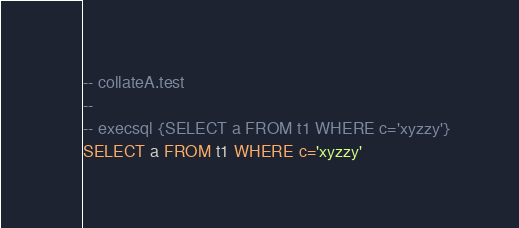Convert code to text. <code><loc_0><loc_0><loc_500><loc_500><_SQL_>-- collateA.test
-- 
-- execsql {SELECT a FROM t1 WHERE c='xyzzy'}
SELECT a FROM t1 WHERE c='xyzzy'</code> 